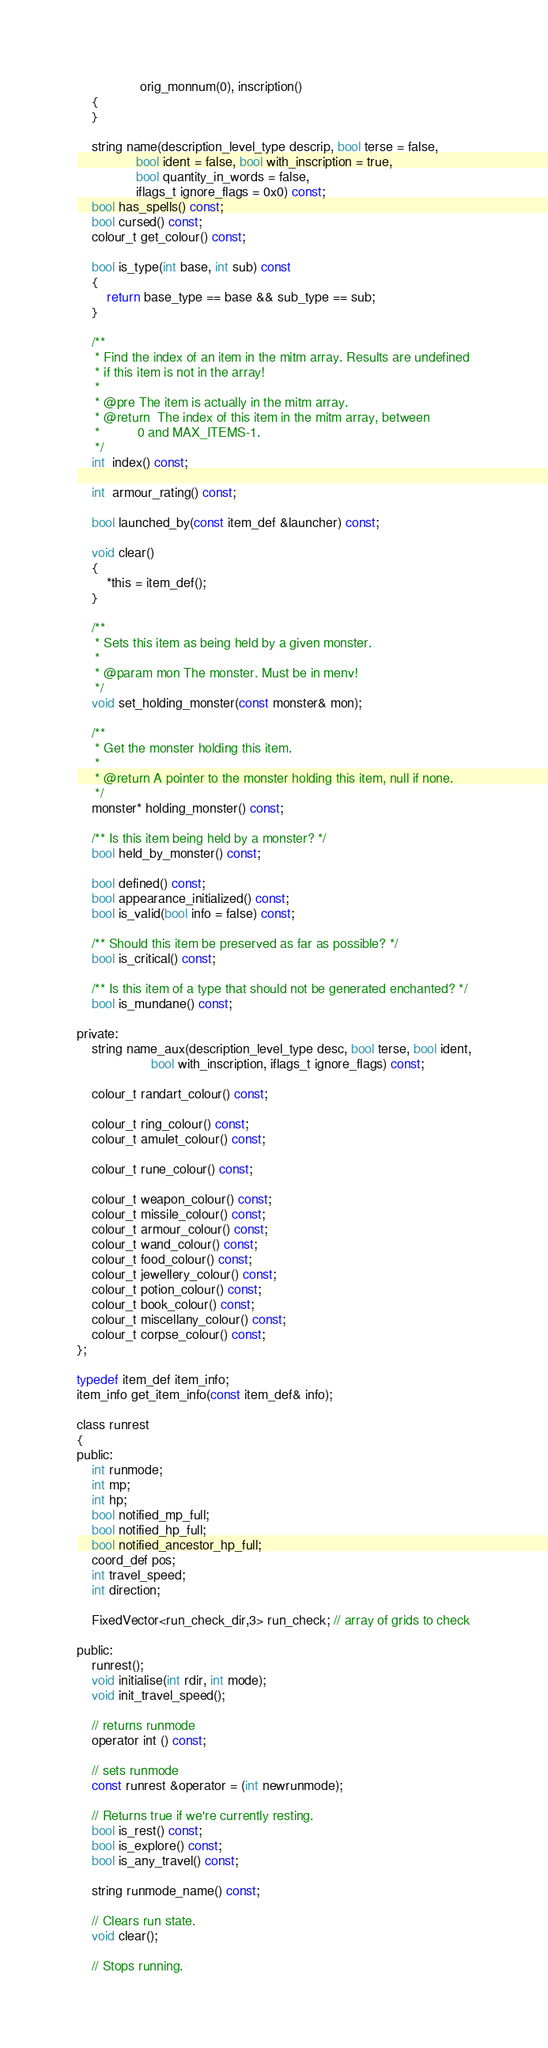<code> <loc_0><loc_0><loc_500><loc_500><_C_>                 orig_monnum(0), inscription()
    {
    }

    string name(description_level_type descrip, bool terse = false,
                bool ident = false, bool with_inscription = true,
                bool quantity_in_words = false,
                iflags_t ignore_flags = 0x0) const;
    bool has_spells() const;
    bool cursed() const;
    colour_t get_colour() const;

    bool is_type(int base, int sub) const
    {
        return base_type == base && sub_type == sub;
    }

    /**
     * Find the index of an item in the mitm array. Results are undefined
     * if this item is not in the array!
     *
     * @pre The item is actually in the mitm array.
     * @return  The index of this item in the mitm array, between
     *          0 and MAX_ITEMS-1.
     */
    int  index() const;

    int  armour_rating() const;

    bool launched_by(const item_def &launcher) const;

    void clear()
    {
        *this = item_def();
    }

    /**
     * Sets this item as being held by a given monster.
     *
     * @param mon The monster. Must be in menv!
     */
    void set_holding_monster(const monster& mon);

    /**
     * Get the monster holding this item.
     *
     * @return A pointer to the monster holding this item, null if none.
     */
    monster* holding_monster() const;

    /** Is this item being held by a monster? */
    bool held_by_monster() const;

    bool defined() const;
    bool appearance_initialized() const;
    bool is_valid(bool info = false) const;

    /** Should this item be preserved as far as possible? */
    bool is_critical() const;

    /** Is this item of a type that should not be generated enchanted? */
    bool is_mundane() const;

private:
    string name_aux(description_level_type desc, bool terse, bool ident,
                    bool with_inscription, iflags_t ignore_flags) const;

    colour_t randart_colour() const;

    colour_t ring_colour() const;
    colour_t amulet_colour() const;

    colour_t rune_colour() const;

    colour_t weapon_colour() const;
    colour_t missile_colour() const;
    colour_t armour_colour() const;
    colour_t wand_colour() const;
    colour_t food_colour() const;
    colour_t jewellery_colour() const;
    colour_t potion_colour() const;
    colour_t book_colour() const;
    colour_t miscellany_colour() const;
    colour_t corpse_colour() const;
};

typedef item_def item_info;
item_info get_item_info(const item_def& info);

class runrest
{
public:
    int runmode;
    int mp;
    int hp;
    bool notified_mp_full;
    bool notified_hp_full;
    bool notified_ancestor_hp_full;
    coord_def pos;
    int travel_speed;
    int direction;

    FixedVector<run_check_dir,3> run_check; // array of grids to check

public:
    runrest();
    void initialise(int rdir, int mode);
    void init_travel_speed();

    // returns runmode
    operator int () const;

    // sets runmode
    const runrest &operator = (int newrunmode);

    // Returns true if we're currently resting.
    bool is_rest() const;
    bool is_explore() const;
    bool is_any_travel() const;

    string runmode_name() const;

    // Clears run state.
    void clear();

    // Stops running.</code> 